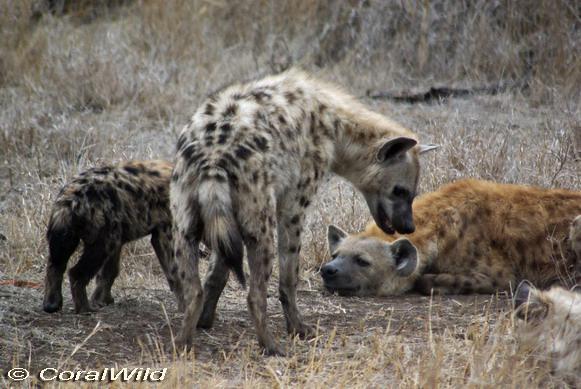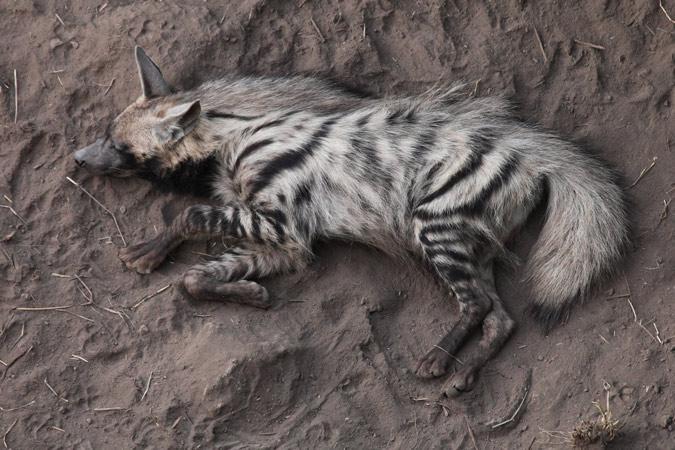The first image is the image on the left, the second image is the image on the right. For the images displayed, is the sentence "One of the animals on the right is baring its teeth." factually correct? Answer yes or no. No. The first image is the image on the left, the second image is the image on the right. Considering the images on both sides, is "An image shows only an upright hyena with erect hair running the length of its body." valid? Answer yes or no. No. 